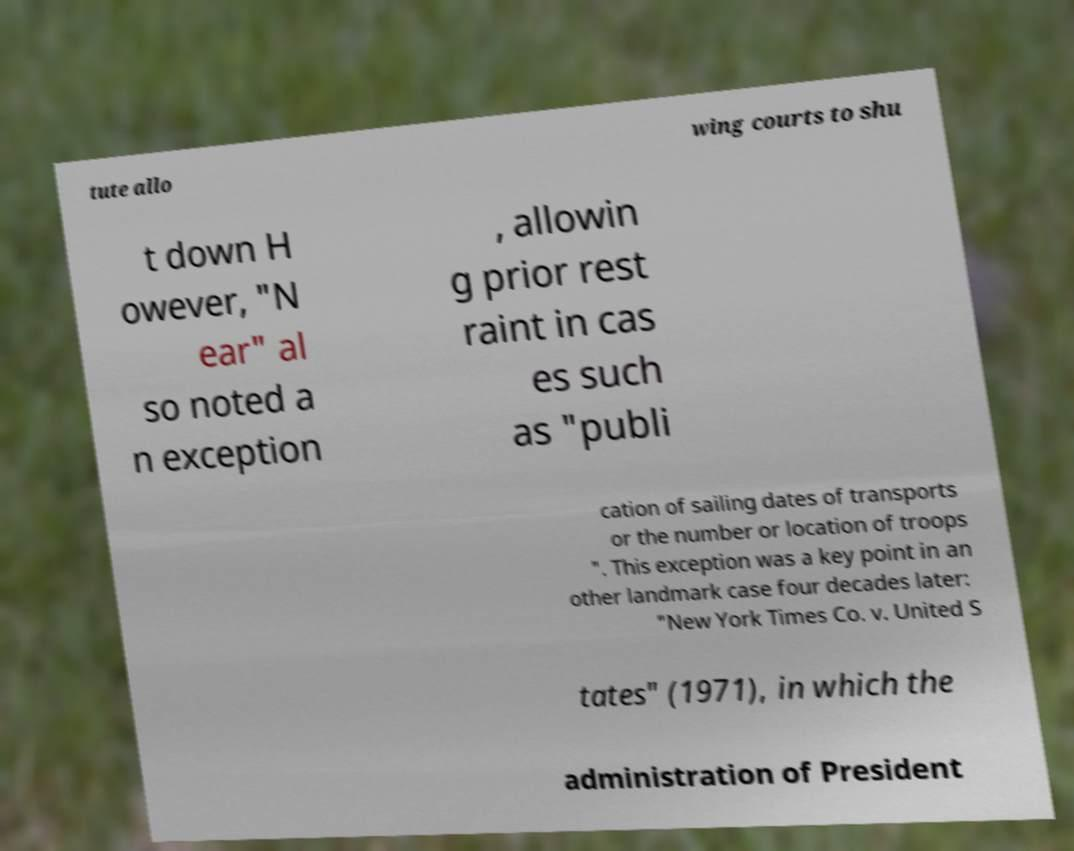What messages or text are displayed in this image? I need them in a readable, typed format. tute allo wing courts to shu t down H owever, "N ear" al so noted a n exception , allowin g prior rest raint in cas es such as "publi cation of sailing dates of transports or the number or location of troops ". This exception was a key point in an other landmark case four decades later: "New York Times Co. v. United S tates" (1971), in which the administration of President 